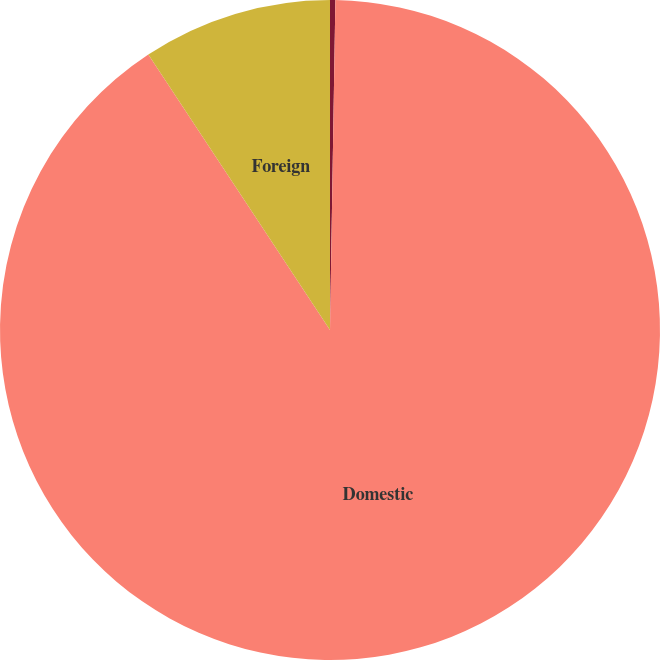Convert chart to OTSL. <chart><loc_0><loc_0><loc_500><loc_500><pie_chart><fcel>Year Ended April 30<fcel>Domestic<fcel>Foreign<nl><fcel>0.26%<fcel>90.47%<fcel>9.28%<nl></chart> 